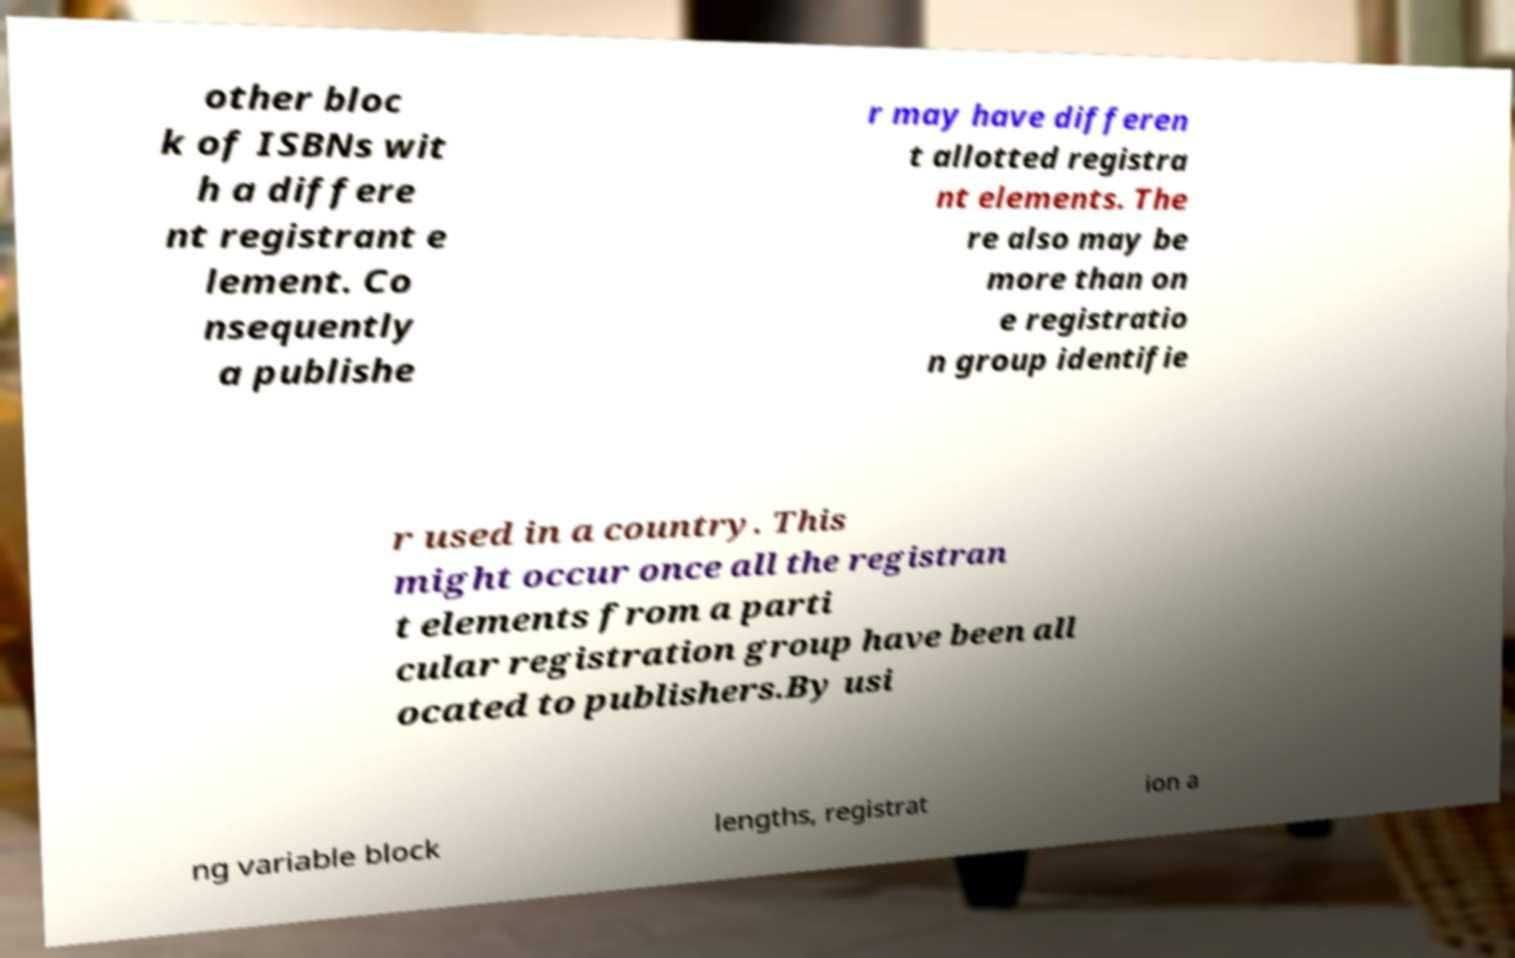Could you extract and type out the text from this image? other bloc k of ISBNs wit h a differe nt registrant e lement. Co nsequently a publishe r may have differen t allotted registra nt elements. The re also may be more than on e registratio n group identifie r used in a country. This might occur once all the registran t elements from a parti cular registration group have been all ocated to publishers.By usi ng variable block lengths, registrat ion a 